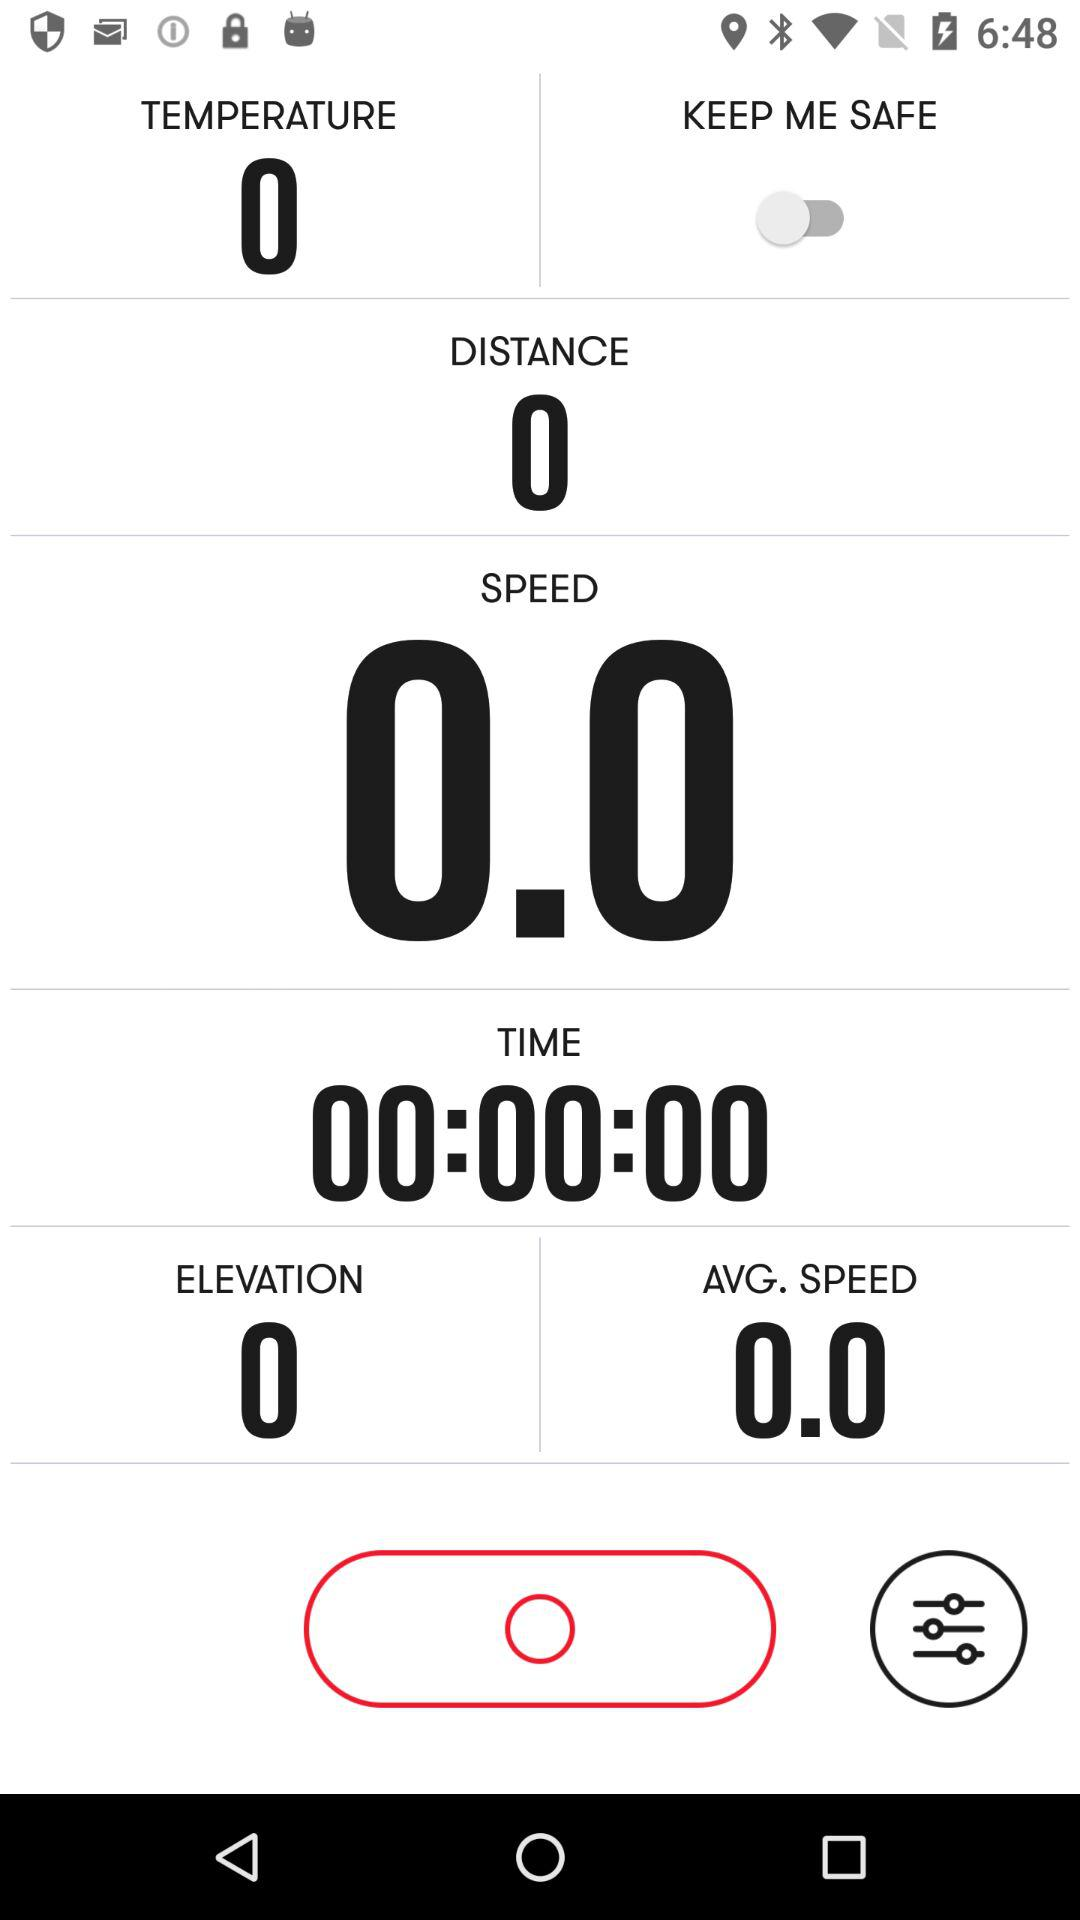What is the total time spent on this activity?
Answer the question using a single word or phrase. 00:00:00 